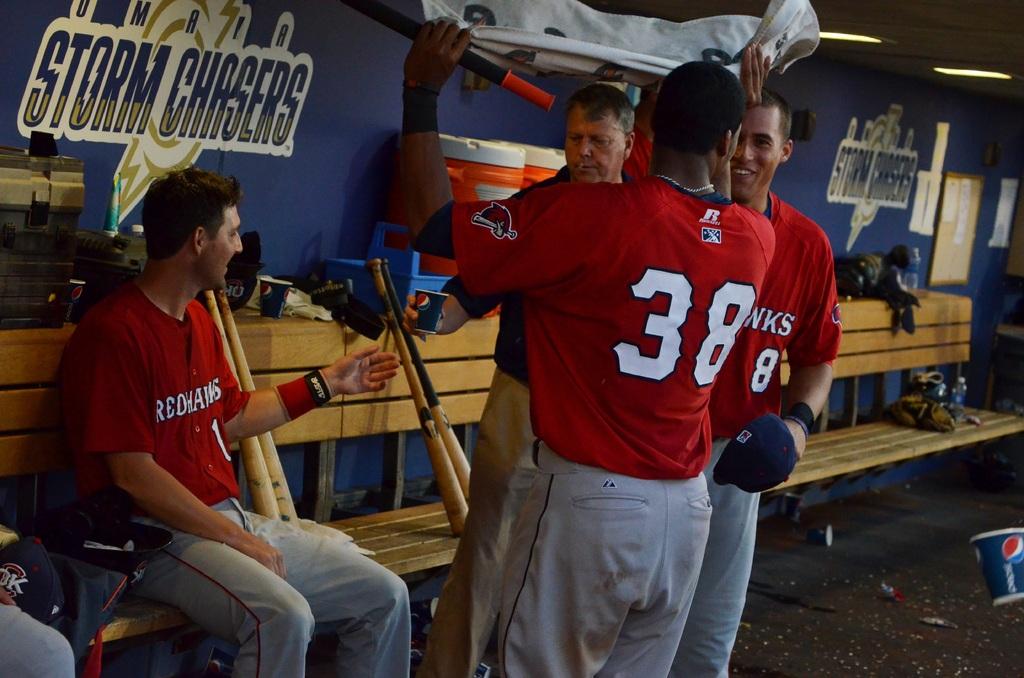What team is referenced on the wall here?
Offer a very short reply. Storm chasers. What number is shown on the player's shirt with his back shown?
Your response must be concise. 38. 